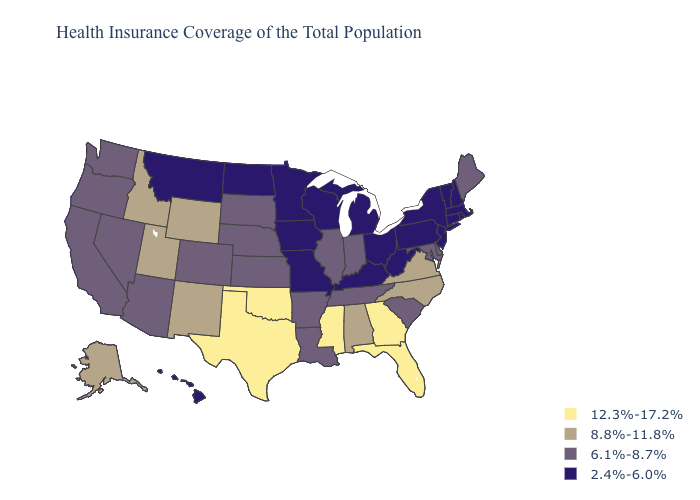What is the value of Alabama?
Give a very brief answer. 8.8%-11.8%. Name the states that have a value in the range 2.4%-6.0%?
Answer briefly. Connecticut, Hawaii, Iowa, Kentucky, Massachusetts, Michigan, Minnesota, Missouri, Montana, New Hampshire, New Jersey, New York, North Dakota, Ohio, Pennsylvania, Rhode Island, Vermont, West Virginia, Wisconsin. Among the states that border Michigan , does Indiana have the lowest value?
Keep it brief. No. Which states have the lowest value in the MidWest?
Short answer required. Iowa, Michigan, Minnesota, Missouri, North Dakota, Ohio, Wisconsin. What is the highest value in the Northeast ?
Give a very brief answer. 6.1%-8.7%. Does Washington have the lowest value in the USA?
Quick response, please. No. Which states have the lowest value in the South?
Answer briefly. Kentucky, West Virginia. What is the value of Maryland?
Quick response, please. 6.1%-8.7%. Name the states that have a value in the range 6.1%-8.7%?
Be succinct. Arizona, Arkansas, California, Colorado, Delaware, Illinois, Indiana, Kansas, Louisiana, Maine, Maryland, Nebraska, Nevada, Oregon, South Carolina, South Dakota, Tennessee, Washington. What is the value of Connecticut?
Short answer required. 2.4%-6.0%. Among the states that border Missouri , which have the lowest value?
Concise answer only. Iowa, Kentucky. What is the lowest value in the West?
Be succinct. 2.4%-6.0%. Which states hav the highest value in the MidWest?
Write a very short answer. Illinois, Indiana, Kansas, Nebraska, South Dakota. Does Maine have the highest value in the Northeast?
Write a very short answer. Yes. What is the highest value in states that border Connecticut?
Short answer required. 2.4%-6.0%. 